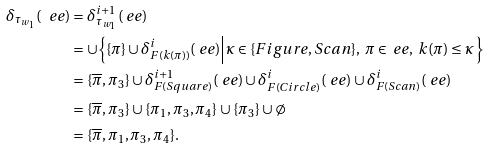Convert formula to latex. <formula><loc_0><loc_0><loc_500><loc_500>\delta _ { \tau _ { w _ { 1 } } } ( \ e e ) & = \delta ^ { i + 1 } _ { \tau _ { w _ { 1 } } } ( \ e e ) \\ & = \cup \Big \{ \{ \pi \} \cup \delta ^ { i } _ { F ( k ( \pi ) ) } ( \ e e ) \Big | \kappa \in \{ F i g u r e , S c a n \} , \ \pi \in \ e e , \ k ( \pi ) \leq \kappa \, \Big \} \\ & = \{ \overline { \pi } , \pi _ { 3 } \} \cup \delta ^ { i + 1 } _ { F ( S q u a r e ) } ( \ e e ) \cup \delta ^ { i } _ { F ( C i r c l e ) } ( \ e e ) \cup \delta ^ { i } _ { F ( S c a n ) } ( \ e e ) \\ & = \{ \overline { \pi } , \pi _ { 3 } \} \cup \{ \pi _ { 1 } , \pi _ { 3 } , \pi _ { 4 } \} \cup \{ \pi _ { 3 } \} \cup \emptyset \\ & = \{ \overline { \pi } , \pi _ { 1 } , \pi _ { 3 } , \pi _ { 4 } \} .</formula> 